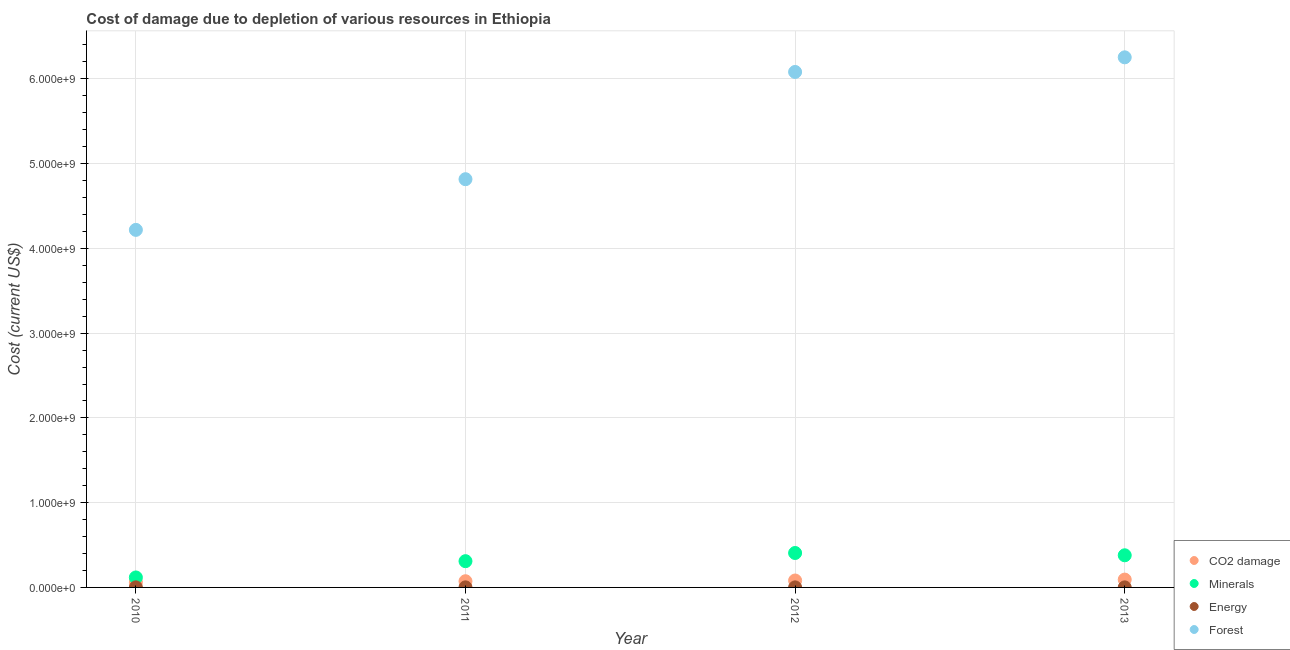How many different coloured dotlines are there?
Your answer should be very brief. 4. What is the cost of damage due to depletion of energy in 2010?
Make the answer very short. 1.04e+06. Across all years, what is the maximum cost of damage due to depletion of energy?
Your answer should be compact. 1.04e+06. Across all years, what is the minimum cost of damage due to depletion of energy?
Your answer should be very brief. 6.23e+05. In which year was the cost of damage due to depletion of forests maximum?
Your response must be concise. 2013. In which year was the cost of damage due to depletion of coal minimum?
Your answer should be very brief. 2010. What is the total cost of damage due to depletion of minerals in the graph?
Your response must be concise. 1.21e+09. What is the difference between the cost of damage due to depletion of coal in 2012 and that in 2013?
Your answer should be compact. -1.09e+07. What is the difference between the cost of damage due to depletion of forests in 2013 and the cost of damage due to depletion of coal in 2012?
Offer a terse response. 6.17e+09. What is the average cost of damage due to depletion of forests per year?
Ensure brevity in your answer.  5.34e+09. In the year 2011, what is the difference between the cost of damage due to depletion of forests and cost of damage due to depletion of minerals?
Your answer should be very brief. 4.51e+09. In how many years, is the cost of damage due to depletion of energy greater than 5000000000 US$?
Provide a succinct answer. 0. What is the ratio of the cost of damage due to depletion of minerals in 2010 to that in 2013?
Your response must be concise. 0.31. Is the cost of damage due to depletion of coal in 2011 less than that in 2013?
Give a very brief answer. Yes. Is the difference between the cost of damage due to depletion of minerals in 2011 and 2013 greater than the difference between the cost of damage due to depletion of energy in 2011 and 2013?
Offer a very short reply. No. What is the difference between the highest and the second highest cost of damage due to depletion of coal?
Your answer should be compact. 1.09e+07. What is the difference between the highest and the lowest cost of damage due to depletion of forests?
Make the answer very short. 2.04e+09. Is it the case that in every year, the sum of the cost of damage due to depletion of coal and cost of damage due to depletion of minerals is greater than the cost of damage due to depletion of energy?
Provide a succinct answer. Yes. Does the cost of damage due to depletion of forests monotonically increase over the years?
Make the answer very short. Yes. Is the cost of damage due to depletion of coal strictly less than the cost of damage due to depletion of forests over the years?
Your answer should be very brief. Yes. How many dotlines are there?
Your response must be concise. 4. How many years are there in the graph?
Provide a succinct answer. 4. What is the difference between two consecutive major ticks on the Y-axis?
Offer a terse response. 1.00e+09. Does the graph contain grids?
Offer a very short reply. Yes. How many legend labels are there?
Ensure brevity in your answer.  4. How are the legend labels stacked?
Offer a terse response. Vertical. What is the title of the graph?
Your response must be concise. Cost of damage due to depletion of various resources in Ethiopia . What is the label or title of the X-axis?
Keep it short and to the point. Year. What is the label or title of the Y-axis?
Offer a very short reply. Cost (current US$). What is the Cost (current US$) in CO2 damage in 2010?
Offer a very short reply. 6.22e+07. What is the Cost (current US$) in Minerals in 2010?
Offer a very short reply. 1.18e+08. What is the Cost (current US$) in Energy in 2010?
Your response must be concise. 1.04e+06. What is the Cost (current US$) in Forest in 2010?
Your response must be concise. 4.22e+09. What is the Cost (current US$) in CO2 damage in 2011?
Provide a succinct answer. 7.31e+07. What is the Cost (current US$) of Minerals in 2011?
Provide a succinct answer. 3.10e+08. What is the Cost (current US$) in Energy in 2011?
Ensure brevity in your answer.  9.09e+05. What is the Cost (current US$) of Forest in 2011?
Offer a very short reply. 4.82e+09. What is the Cost (current US$) of CO2 damage in 2012?
Your response must be concise. 8.17e+07. What is the Cost (current US$) of Minerals in 2012?
Your answer should be very brief. 4.06e+08. What is the Cost (current US$) of Energy in 2012?
Your response must be concise. 6.99e+05. What is the Cost (current US$) in Forest in 2012?
Provide a succinct answer. 6.08e+09. What is the Cost (current US$) of CO2 damage in 2013?
Provide a succinct answer. 9.26e+07. What is the Cost (current US$) in Minerals in 2013?
Offer a very short reply. 3.79e+08. What is the Cost (current US$) of Energy in 2013?
Your response must be concise. 6.23e+05. What is the Cost (current US$) in Forest in 2013?
Your answer should be very brief. 6.25e+09. Across all years, what is the maximum Cost (current US$) of CO2 damage?
Your answer should be very brief. 9.26e+07. Across all years, what is the maximum Cost (current US$) in Minerals?
Offer a terse response. 4.06e+08. Across all years, what is the maximum Cost (current US$) of Energy?
Your answer should be compact. 1.04e+06. Across all years, what is the maximum Cost (current US$) of Forest?
Give a very brief answer. 6.25e+09. Across all years, what is the minimum Cost (current US$) in CO2 damage?
Offer a very short reply. 6.22e+07. Across all years, what is the minimum Cost (current US$) of Minerals?
Your response must be concise. 1.18e+08. Across all years, what is the minimum Cost (current US$) in Energy?
Keep it short and to the point. 6.23e+05. Across all years, what is the minimum Cost (current US$) in Forest?
Ensure brevity in your answer.  4.22e+09. What is the total Cost (current US$) of CO2 damage in the graph?
Your answer should be very brief. 3.10e+08. What is the total Cost (current US$) in Minerals in the graph?
Keep it short and to the point. 1.21e+09. What is the total Cost (current US$) of Energy in the graph?
Provide a succinct answer. 3.28e+06. What is the total Cost (current US$) of Forest in the graph?
Provide a succinct answer. 2.14e+1. What is the difference between the Cost (current US$) in CO2 damage in 2010 and that in 2011?
Keep it short and to the point. -1.09e+07. What is the difference between the Cost (current US$) in Minerals in 2010 and that in 2011?
Your answer should be compact. -1.92e+08. What is the difference between the Cost (current US$) of Energy in 2010 and that in 2011?
Provide a succinct answer. 1.36e+05. What is the difference between the Cost (current US$) in Forest in 2010 and that in 2011?
Provide a succinct answer. -5.98e+08. What is the difference between the Cost (current US$) in CO2 damage in 2010 and that in 2012?
Make the answer very short. -1.95e+07. What is the difference between the Cost (current US$) in Minerals in 2010 and that in 2012?
Ensure brevity in your answer.  -2.88e+08. What is the difference between the Cost (current US$) of Energy in 2010 and that in 2012?
Your answer should be very brief. 3.46e+05. What is the difference between the Cost (current US$) in Forest in 2010 and that in 2012?
Your answer should be very brief. -1.86e+09. What is the difference between the Cost (current US$) of CO2 damage in 2010 and that in 2013?
Keep it short and to the point. -3.04e+07. What is the difference between the Cost (current US$) of Minerals in 2010 and that in 2013?
Offer a very short reply. -2.61e+08. What is the difference between the Cost (current US$) of Energy in 2010 and that in 2013?
Offer a terse response. 4.21e+05. What is the difference between the Cost (current US$) of Forest in 2010 and that in 2013?
Give a very brief answer. -2.04e+09. What is the difference between the Cost (current US$) of CO2 damage in 2011 and that in 2012?
Your answer should be compact. -8.60e+06. What is the difference between the Cost (current US$) of Minerals in 2011 and that in 2012?
Keep it short and to the point. -9.64e+07. What is the difference between the Cost (current US$) in Energy in 2011 and that in 2012?
Offer a terse response. 2.10e+05. What is the difference between the Cost (current US$) in Forest in 2011 and that in 2012?
Make the answer very short. -1.27e+09. What is the difference between the Cost (current US$) of CO2 damage in 2011 and that in 2013?
Offer a terse response. -1.95e+07. What is the difference between the Cost (current US$) of Minerals in 2011 and that in 2013?
Give a very brief answer. -6.94e+07. What is the difference between the Cost (current US$) in Energy in 2011 and that in 2013?
Provide a succinct answer. 2.85e+05. What is the difference between the Cost (current US$) in Forest in 2011 and that in 2013?
Offer a terse response. -1.44e+09. What is the difference between the Cost (current US$) in CO2 damage in 2012 and that in 2013?
Give a very brief answer. -1.09e+07. What is the difference between the Cost (current US$) in Minerals in 2012 and that in 2013?
Your answer should be compact. 2.70e+07. What is the difference between the Cost (current US$) in Energy in 2012 and that in 2013?
Your answer should be very brief. 7.53e+04. What is the difference between the Cost (current US$) of Forest in 2012 and that in 2013?
Your response must be concise. -1.73e+08. What is the difference between the Cost (current US$) of CO2 damage in 2010 and the Cost (current US$) of Minerals in 2011?
Provide a succinct answer. -2.48e+08. What is the difference between the Cost (current US$) of CO2 damage in 2010 and the Cost (current US$) of Energy in 2011?
Your answer should be compact. 6.13e+07. What is the difference between the Cost (current US$) in CO2 damage in 2010 and the Cost (current US$) in Forest in 2011?
Your response must be concise. -4.75e+09. What is the difference between the Cost (current US$) of Minerals in 2010 and the Cost (current US$) of Energy in 2011?
Your answer should be very brief. 1.17e+08. What is the difference between the Cost (current US$) in Minerals in 2010 and the Cost (current US$) in Forest in 2011?
Offer a terse response. -4.70e+09. What is the difference between the Cost (current US$) of Energy in 2010 and the Cost (current US$) of Forest in 2011?
Ensure brevity in your answer.  -4.82e+09. What is the difference between the Cost (current US$) in CO2 damage in 2010 and the Cost (current US$) in Minerals in 2012?
Ensure brevity in your answer.  -3.44e+08. What is the difference between the Cost (current US$) in CO2 damage in 2010 and the Cost (current US$) in Energy in 2012?
Give a very brief answer. 6.15e+07. What is the difference between the Cost (current US$) of CO2 damage in 2010 and the Cost (current US$) of Forest in 2012?
Make the answer very short. -6.02e+09. What is the difference between the Cost (current US$) in Minerals in 2010 and the Cost (current US$) in Energy in 2012?
Make the answer very short. 1.17e+08. What is the difference between the Cost (current US$) in Minerals in 2010 and the Cost (current US$) in Forest in 2012?
Ensure brevity in your answer.  -5.96e+09. What is the difference between the Cost (current US$) of Energy in 2010 and the Cost (current US$) of Forest in 2012?
Provide a succinct answer. -6.08e+09. What is the difference between the Cost (current US$) in CO2 damage in 2010 and the Cost (current US$) in Minerals in 2013?
Provide a short and direct response. -3.17e+08. What is the difference between the Cost (current US$) of CO2 damage in 2010 and the Cost (current US$) of Energy in 2013?
Ensure brevity in your answer.  6.16e+07. What is the difference between the Cost (current US$) of CO2 damage in 2010 and the Cost (current US$) of Forest in 2013?
Offer a terse response. -6.19e+09. What is the difference between the Cost (current US$) in Minerals in 2010 and the Cost (current US$) in Energy in 2013?
Make the answer very short. 1.17e+08. What is the difference between the Cost (current US$) of Minerals in 2010 and the Cost (current US$) of Forest in 2013?
Your answer should be very brief. -6.14e+09. What is the difference between the Cost (current US$) in Energy in 2010 and the Cost (current US$) in Forest in 2013?
Keep it short and to the point. -6.25e+09. What is the difference between the Cost (current US$) in CO2 damage in 2011 and the Cost (current US$) in Minerals in 2012?
Your response must be concise. -3.33e+08. What is the difference between the Cost (current US$) of CO2 damage in 2011 and the Cost (current US$) of Energy in 2012?
Keep it short and to the point. 7.24e+07. What is the difference between the Cost (current US$) of CO2 damage in 2011 and the Cost (current US$) of Forest in 2012?
Your answer should be very brief. -6.01e+09. What is the difference between the Cost (current US$) of Minerals in 2011 and the Cost (current US$) of Energy in 2012?
Provide a short and direct response. 3.09e+08. What is the difference between the Cost (current US$) in Minerals in 2011 and the Cost (current US$) in Forest in 2012?
Provide a short and direct response. -5.77e+09. What is the difference between the Cost (current US$) in Energy in 2011 and the Cost (current US$) in Forest in 2012?
Give a very brief answer. -6.08e+09. What is the difference between the Cost (current US$) in CO2 damage in 2011 and the Cost (current US$) in Minerals in 2013?
Make the answer very short. -3.06e+08. What is the difference between the Cost (current US$) of CO2 damage in 2011 and the Cost (current US$) of Energy in 2013?
Give a very brief answer. 7.25e+07. What is the difference between the Cost (current US$) in CO2 damage in 2011 and the Cost (current US$) in Forest in 2013?
Offer a very short reply. -6.18e+09. What is the difference between the Cost (current US$) in Minerals in 2011 and the Cost (current US$) in Energy in 2013?
Give a very brief answer. 3.09e+08. What is the difference between the Cost (current US$) of Minerals in 2011 and the Cost (current US$) of Forest in 2013?
Your answer should be very brief. -5.94e+09. What is the difference between the Cost (current US$) in Energy in 2011 and the Cost (current US$) in Forest in 2013?
Your response must be concise. -6.25e+09. What is the difference between the Cost (current US$) in CO2 damage in 2012 and the Cost (current US$) in Minerals in 2013?
Your response must be concise. -2.98e+08. What is the difference between the Cost (current US$) in CO2 damage in 2012 and the Cost (current US$) in Energy in 2013?
Provide a succinct answer. 8.11e+07. What is the difference between the Cost (current US$) in CO2 damage in 2012 and the Cost (current US$) in Forest in 2013?
Provide a short and direct response. -6.17e+09. What is the difference between the Cost (current US$) in Minerals in 2012 and the Cost (current US$) in Energy in 2013?
Give a very brief answer. 4.06e+08. What is the difference between the Cost (current US$) of Minerals in 2012 and the Cost (current US$) of Forest in 2013?
Give a very brief answer. -5.85e+09. What is the difference between the Cost (current US$) in Energy in 2012 and the Cost (current US$) in Forest in 2013?
Your answer should be compact. -6.25e+09. What is the average Cost (current US$) of CO2 damage per year?
Provide a succinct answer. 7.74e+07. What is the average Cost (current US$) in Minerals per year?
Offer a very short reply. 3.03e+08. What is the average Cost (current US$) of Energy per year?
Provide a short and direct response. 8.19e+05. What is the average Cost (current US$) in Forest per year?
Ensure brevity in your answer.  5.34e+09. In the year 2010, what is the difference between the Cost (current US$) of CO2 damage and Cost (current US$) of Minerals?
Provide a succinct answer. -5.56e+07. In the year 2010, what is the difference between the Cost (current US$) of CO2 damage and Cost (current US$) of Energy?
Keep it short and to the point. 6.12e+07. In the year 2010, what is the difference between the Cost (current US$) in CO2 damage and Cost (current US$) in Forest?
Your answer should be compact. -4.16e+09. In the year 2010, what is the difference between the Cost (current US$) of Minerals and Cost (current US$) of Energy?
Give a very brief answer. 1.17e+08. In the year 2010, what is the difference between the Cost (current US$) of Minerals and Cost (current US$) of Forest?
Provide a succinct answer. -4.10e+09. In the year 2010, what is the difference between the Cost (current US$) of Energy and Cost (current US$) of Forest?
Your answer should be compact. -4.22e+09. In the year 2011, what is the difference between the Cost (current US$) in CO2 damage and Cost (current US$) in Minerals?
Your answer should be compact. -2.37e+08. In the year 2011, what is the difference between the Cost (current US$) in CO2 damage and Cost (current US$) in Energy?
Make the answer very short. 7.22e+07. In the year 2011, what is the difference between the Cost (current US$) in CO2 damage and Cost (current US$) in Forest?
Provide a succinct answer. -4.74e+09. In the year 2011, what is the difference between the Cost (current US$) of Minerals and Cost (current US$) of Energy?
Give a very brief answer. 3.09e+08. In the year 2011, what is the difference between the Cost (current US$) of Minerals and Cost (current US$) of Forest?
Ensure brevity in your answer.  -4.51e+09. In the year 2011, what is the difference between the Cost (current US$) of Energy and Cost (current US$) of Forest?
Your answer should be very brief. -4.82e+09. In the year 2012, what is the difference between the Cost (current US$) in CO2 damage and Cost (current US$) in Minerals?
Ensure brevity in your answer.  -3.24e+08. In the year 2012, what is the difference between the Cost (current US$) in CO2 damage and Cost (current US$) in Energy?
Ensure brevity in your answer.  8.10e+07. In the year 2012, what is the difference between the Cost (current US$) of CO2 damage and Cost (current US$) of Forest?
Ensure brevity in your answer.  -6.00e+09. In the year 2012, what is the difference between the Cost (current US$) of Minerals and Cost (current US$) of Energy?
Provide a succinct answer. 4.06e+08. In the year 2012, what is the difference between the Cost (current US$) in Minerals and Cost (current US$) in Forest?
Ensure brevity in your answer.  -5.68e+09. In the year 2012, what is the difference between the Cost (current US$) in Energy and Cost (current US$) in Forest?
Provide a succinct answer. -6.08e+09. In the year 2013, what is the difference between the Cost (current US$) of CO2 damage and Cost (current US$) of Minerals?
Your answer should be very brief. -2.87e+08. In the year 2013, what is the difference between the Cost (current US$) in CO2 damage and Cost (current US$) in Energy?
Make the answer very short. 9.20e+07. In the year 2013, what is the difference between the Cost (current US$) of CO2 damage and Cost (current US$) of Forest?
Offer a very short reply. -6.16e+09. In the year 2013, what is the difference between the Cost (current US$) in Minerals and Cost (current US$) in Energy?
Ensure brevity in your answer.  3.79e+08. In the year 2013, what is the difference between the Cost (current US$) in Minerals and Cost (current US$) in Forest?
Provide a short and direct response. -5.87e+09. In the year 2013, what is the difference between the Cost (current US$) in Energy and Cost (current US$) in Forest?
Your answer should be compact. -6.25e+09. What is the ratio of the Cost (current US$) of CO2 damage in 2010 to that in 2011?
Offer a terse response. 0.85. What is the ratio of the Cost (current US$) of Minerals in 2010 to that in 2011?
Your answer should be compact. 0.38. What is the ratio of the Cost (current US$) of Energy in 2010 to that in 2011?
Make the answer very short. 1.15. What is the ratio of the Cost (current US$) of Forest in 2010 to that in 2011?
Offer a terse response. 0.88. What is the ratio of the Cost (current US$) in CO2 damage in 2010 to that in 2012?
Ensure brevity in your answer.  0.76. What is the ratio of the Cost (current US$) of Minerals in 2010 to that in 2012?
Offer a terse response. 0.29. What is the ratio of the Cost (current US$) in Energy in 2010 to that in 2012?
Your answer should be very brief. 1.5. What is the ratio of the Cost (current US$) of Forest in 2010 to that in 2012?
Offer a very short reply. 0.69. What is the ratio of the Cost (current US$) in CO2 damage in 2010 to that in 2013?
Provide a short and direct response. 0.67. What is the ratio of the Cost (current US$) in Minerals in 2010 to that in 2013?
Your response must be concise. 0.31. What is the ratio of the Cost (current US$) of Energy in 2010 to that in 2013?
Make the answer very short. 1.68. What is the ratio of the Cost (current US$) in Forest in 2010 to that in 2013?
Provide a short and direct response. 0.67. What is the ratio of the Cost (current US$) of CO2 damage in 2011 to that in 2012?
Provide a short and direct response. 0.89. What is the ratio of the Cost (current US$) of Minerals in 2011 to that in 2012?
Offer a terse response. 0.76. What is the ratio of the Cost (current US$) in Energy in 2011 to that in 2012?
Give a very brief answer. 1.3. What is the ratio of the Cost (current US$) of Forest in 2011 to that in 2012?
Make the answer very short. 0.79. What is the ratio of the Cost (current US$) in CO2 damage in 2011 to that in 2013?
Your response must be concise. 0.79. What is the ratio of the Cost (current US$) of Minerals in 2011 to that in 2013?
Offer a terse response. 0.82. What is the ratio of the Cost (current US$) of Energy in 2011 to that in 2013?
Ensure brevity in your answer.  1.46. What is the ratio of the Cost (current US$) of Forest in 2011 to that in 2013?
Make the answer very short. 0.77. What is the ratio of the Cost (current US$) of CO2 damage in 2012 to that in 2013?
Provide a succinct answer. 0.88. What is the ratio of the Cost (current US$) of Minerals in 2012 to that in 2013?
Your answer should be very brief. 1.07. What is the ratio of the Cost (current US$) in Energy in 2012 to that in 2013?
Your response must be concise. 1.12. What is the ratio of the Cost (current US$) of Forest in 2012 to that in 2013?
Ensure brevity in your answer.  0.97. What is the difference between the highest and the second highest Cost (current US$) in CO2 damage?
Offer a very short reply. 1.09e+07. What is the difference between the highest and the second highest Cost (current US$) in Minerals?
Make the answer very short. 2.70e+07. What is the difference between the highest and the second highest Cost (current US$) of Energy?
Provide a succinct answer. 1.36e+05. What is the difference between the highest and the second highest Cost (current US$) of Forest?
Make the answer very short. 1.73e+08. What is the difference between the highest and the lowest Cost (current US$) in CO2 damage?
Offer a very short reply. 3.04e+07. What is the difference between the highest and the lowest Cost (current US$) of Minerals?
Keep it short and to the point. 2.88e+08. What is the difference between the highest and the lowest Cost (current US$) in Energy?
Offer a terse response. 4.21e+05. What is the difference between the highest and the lowest Cost (current US$) in Forest?
Provide a succinct answer. 2.04e+09. 